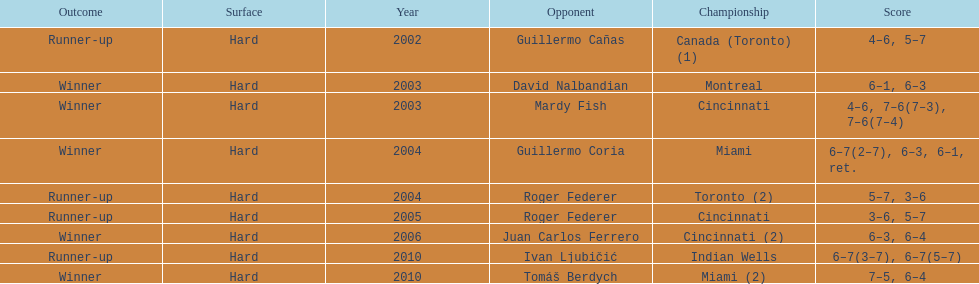How many consecutive years was there a hard surface at the championship? 9. 